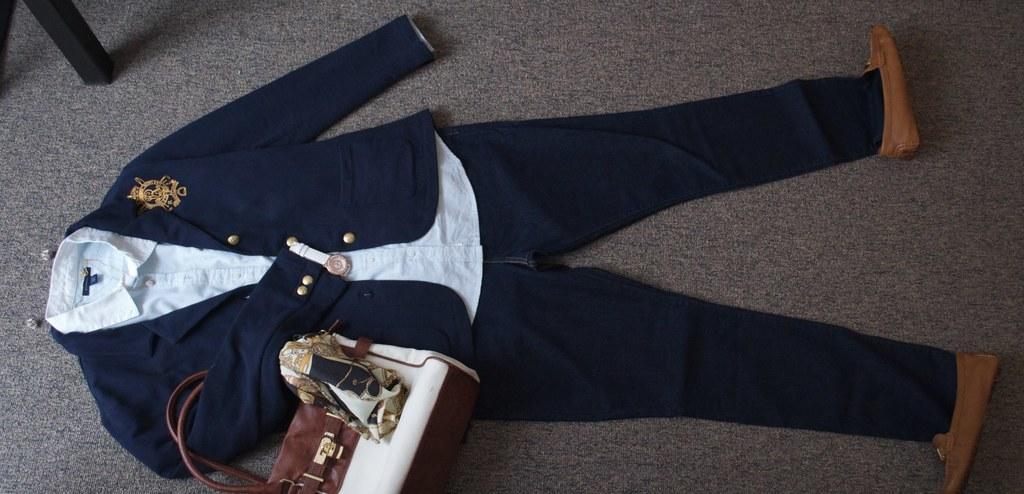Can you describe this image briefly? In this image we can see a dress, handbag and shoes on a surface. In the top left, we can see a wooden object. 